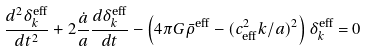Convert formula to latex. <formula><loc_0><loc_0><loc_500><loc_500>\frac { d ^ { 2 } \delta _ { k } ^ { \text {eff} } } { d t ^ { 2 } } + 2 \frac { \dot { a } } { a } \frac { d \delta _ { k } ^ { \text {eff} } } { d t } - \left ( 4 \pi G \bar { \rho } ^ { \text {eff} } - ( c ^ { 2 } _ { \text {eff} } k / a ) ^ { 2 } \right ) \delta _ { k } ^ { \text {eff} } = 0</formula> 